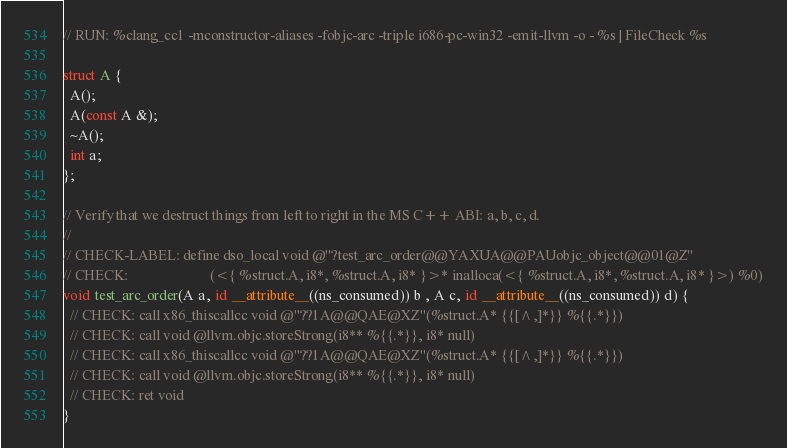<code> <loc_0><loc_0><loc_500><loc_500><_ObjectiveC_>// RUN: %clang_cc1 -mconstructor-aliases -fobjc-arc -triple i686-pc-win32 -emit-llvm -o - %s | FileCheck %s

struct A {
  A();
  A(const A &);
  ~A();
  int a;
};

// Verify that we destruct things from left to right in the MS C++ ABI: a, b, c, d.
//
// CHECK-LABEL: define dso_local void @"?test_arc_order@@YAXUA@@PAUobjc_object@@01@Z"
// CHECK:                       (<{ %struct.A, i8*, %struct.A, i8* }>* inalloca(<{ %struct.A, i8*, %struct.A, i8* }>) %0)
void test_arc_order(A a, id __attribute__((ns_consumed)) b , A c, id __attribute__((ns_consumed)) d) {
  // CHECK: call x86_thiscallcc void @"??1A@@QAE@XZ"(%struct.A* {{[^,]*}} %{{.*}})
  // CHECK: call void @llvm.objc.storeStrong(i8** %{{.*}}, i8* null)
  // CHECK: call x86_thiscallcc void @"??1A@@QAE@XZ"(%struct.A* {{[^,]*}} %{{.*}})
  // CHECK: call void @llvm.objc.storeStrong(i8** %{{.*}}, i8* null)
  // CHECK: ret void
}
</code> 